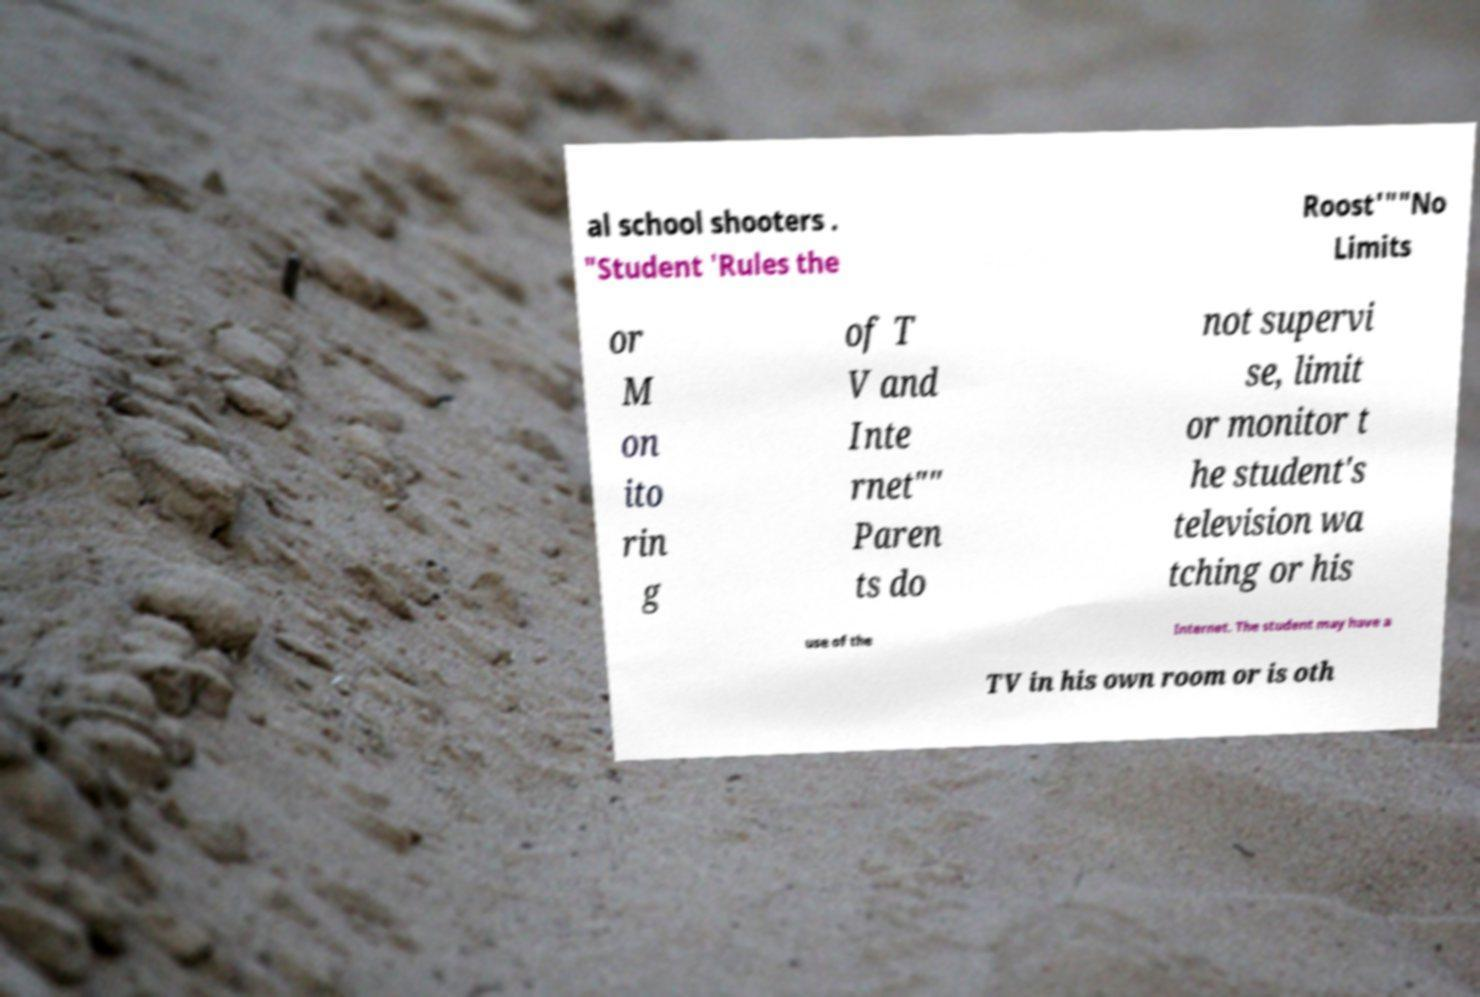Can you read and provide the text displayed in the image?This photo seems to have some interesting text. Can you extract and type it out for me? al school shooters . "Student 'Rules the Roost'""No Limits or M on ito rin g of T V and Inte rnet"" Paren ts do not supervi se, limit or monitor t he student's television wa tching or his use of the Internet. The student may have a TV in his own room or is oth 